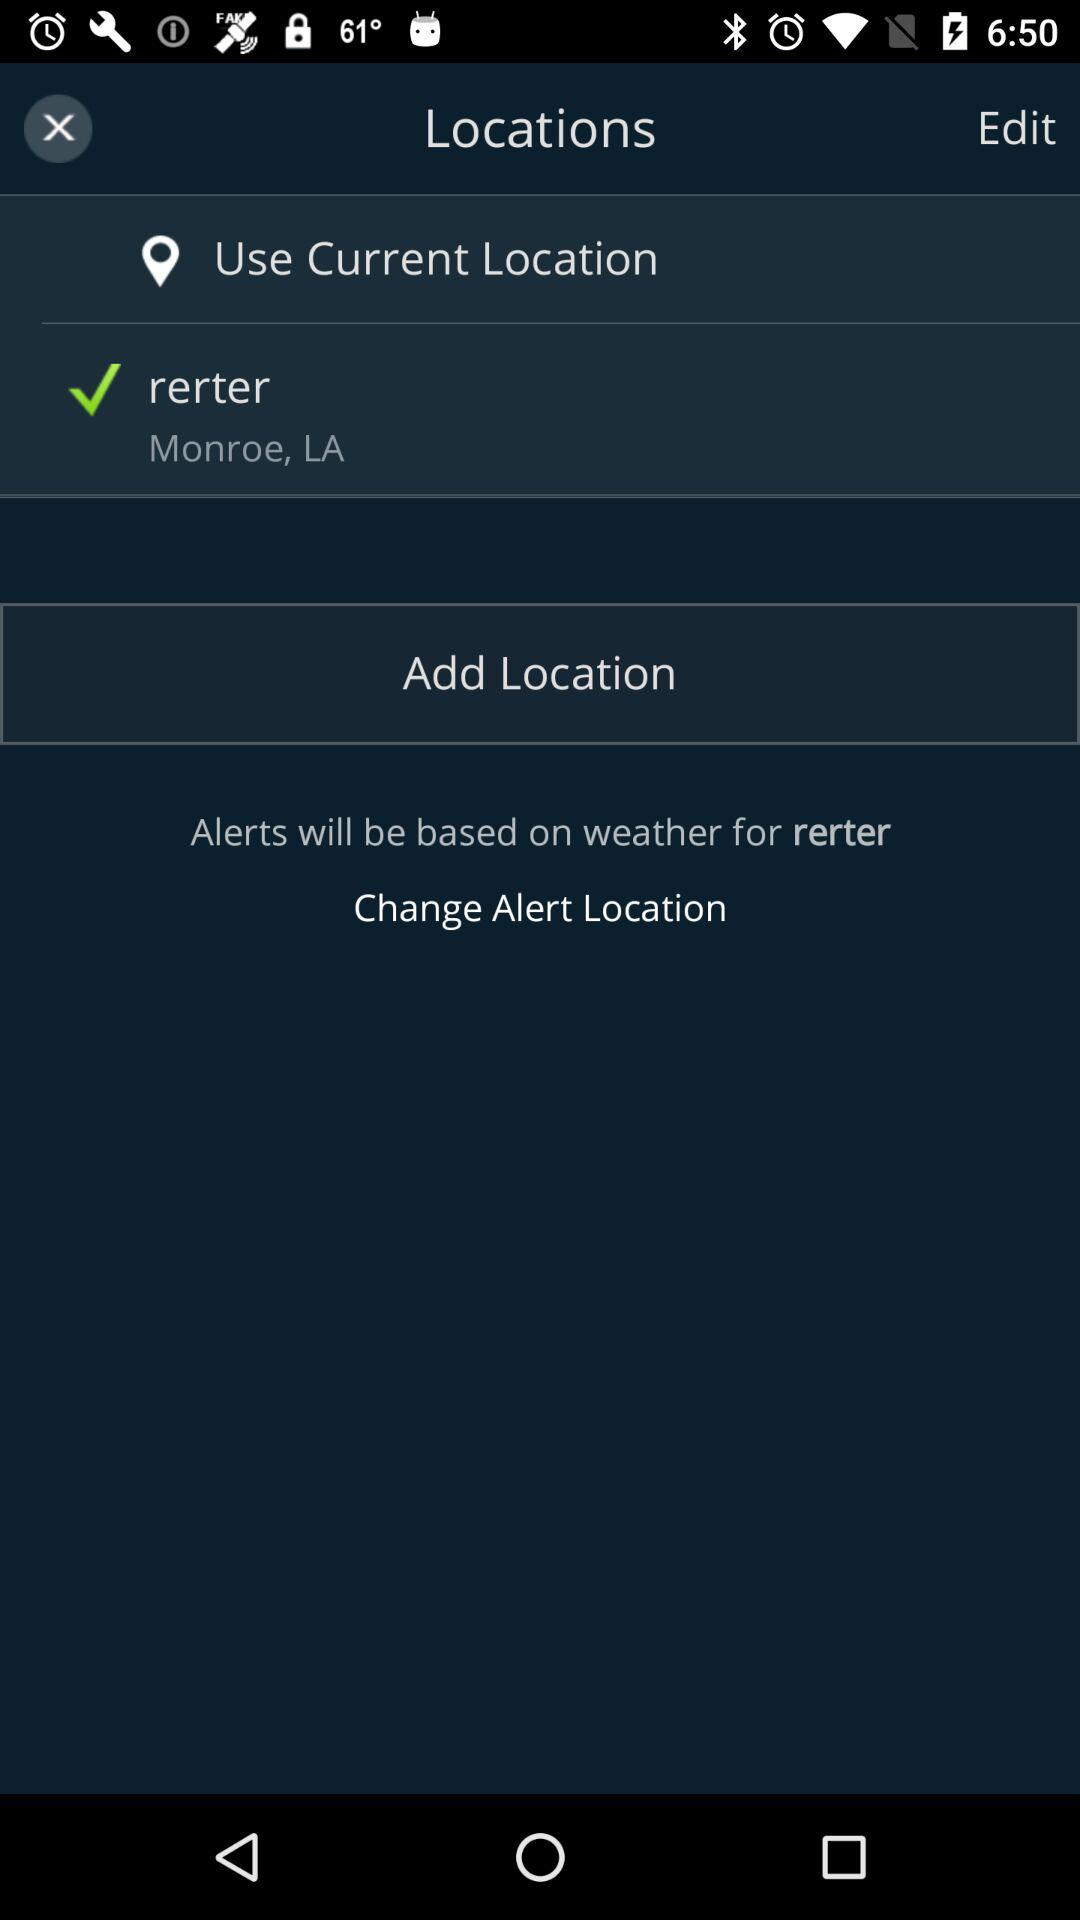What is the name of the location that is not the current location?
Answer the question using a single word or phrase. Rerter 